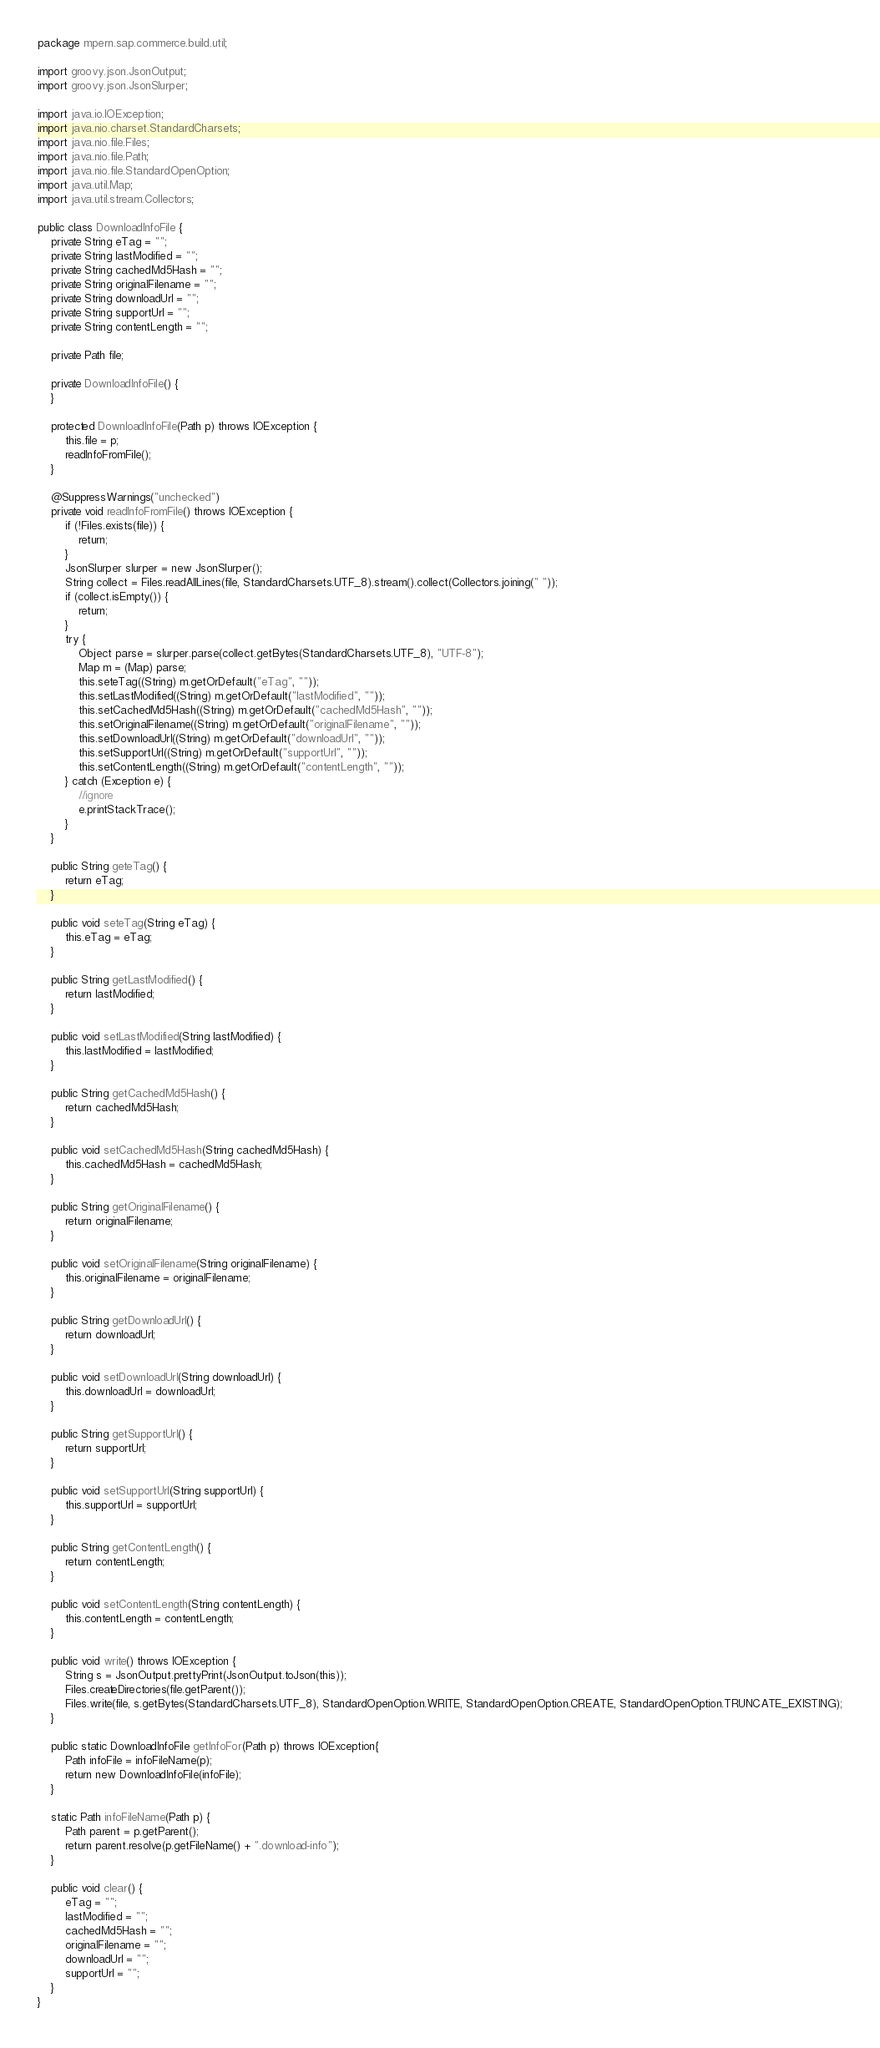Convert code to text. <code><loc_0><loc_0><loc_500><loc_500><_Java_>package mpern.sap.commerce.build.util;

import groovy.json.JsonOutput;
import groovy.json.JsonSlurper;

import java.io.IOException;
import java.nio.charset.StandardCharsets;
import java.nio.file.Files;
import java.nio.file.Path;
import java.nio.file.StandardOpenOption;
import java.util.Map;
import java.util.stream.Collectors;

public class DownloadInfoFile {
    private String eTag = "";
    private String lastModified = "";
    private String cachedMd5Hash = "";
    private String originalFilename = "";
    private String downloadUrl = "";
    private String supportUrl = "";
    private String contentLength = "";

    private Path file;

    private DownloadInfoFile() {
    }

    protected DownloadInfoFile(Path p) throws IOException {
        this.file = p;
        readInfoFromFile();
    }

    @SuppressWarnings("unchecked")
    private void readInfoFromFile() throws IOException {
        if (!Files.exists(file)) {
            return;
        }
        JsonSlurper slurper = new JsonSlurper();
        String collect = Files.readAllLines(file, StandardCharsets.UTF_8).stream().collect(Collectors.joining(" "));
        if (collect.isEmpty()) {
            return;
        }
        try {
            Object parse = slurper.parse(collect.getBytes(StandardCharsets.UTF_8), "UTF-8");
            Map m = (Map) parse;
            this.seteTag((String) m.getOrDefault("eTag", ""));
            this.setLastModified((String) m.getOrDefault("lastModified", ""));
            this.setCachedMd5Hash((String) m.getOrDefault("cachedMd5Hash", ""));
            this.setOriginalFilename((String) m.getOrDefault("originalFilename", ""));
            this.setDownloadUrl((String) m.getOrDefault("downloadUrl", ""));
            this.setSupportUrl((String) m.getOrDefault("supportUrl", ""));
            this.setContentLength((String) m.getOrDefault("contentLength", ""));
        } catch (Exception e) {
            //ignore
            e.printStackTrace();
        }
    }

    public String geteTag() {
        return eTag;
    }

    public void seteTag(String eTag) {
        this.eTag = eTag;
    }

    public String getLastModified() {
        return lastModified;
    }

    public void setLastModified(String lastModified) {
        this.lastModified = lastModified;
    }

    public String getCachedMd5Hash() {
        return cachedMd5Hash;
    }

    public void setCachedMd5Hash(String cachedMd5Hash) {
        this.cachedMd5Hash = cachedMd5Hash;
    }

    public String getOriginalFilename() {
        return originalFilename;
    }

    public void setOriginalFilename(String originalFilename) {
        this.originalFilename = originalFilename;
    }

    public String getDownloadUrl() {
        return downloadUrl;
    }

    public void setDownloadUrl(String downloadUrl) {
        this.downloadUrl = downloadUrl;
    }

    public String getSupportUrl() {
        return supportUrl;
    }

    public void setSupportUrl(String supportUrl) {
        this.supportUrl = supportUrl;
    }

    public String getContentLength() {
        return contentLength;
    }

    public void setContentLength(String contentLength) {
        this.contentLength = contentLength;
    }

    public void write() throws IOException {
        String s = JsonOutput.prettyPrint(JsonOutput.toJson(this));
        Files.createDirectories(file.getParent());
        Files.write(file, s.getBytes(StandardCharsets.UTF_8), StandardOpenOption.WRITE, StandardOpenOption.CREATE, StandardOpenOption.TRUNCATE_EXISTING);
    }

    public static DownloadInfoFile getInfoFor(Path p) throws IOException{
        Path infoFile = infoFileName(p);
        return new DownloadInfoFile(infoFile);
    }

    static Path infoFileName(Path p) {
        Path parent = p.getParent();
        return parent.resolve(p.getFileName() + ".download-info");
    }

    public void clear() {
        eTag = "";
        lastModified = "";
        cachedMd5Hash = "";
        originalFilename = "";
        downloadUrl = "";
        supportUrl = "";
    }
}
</code> 